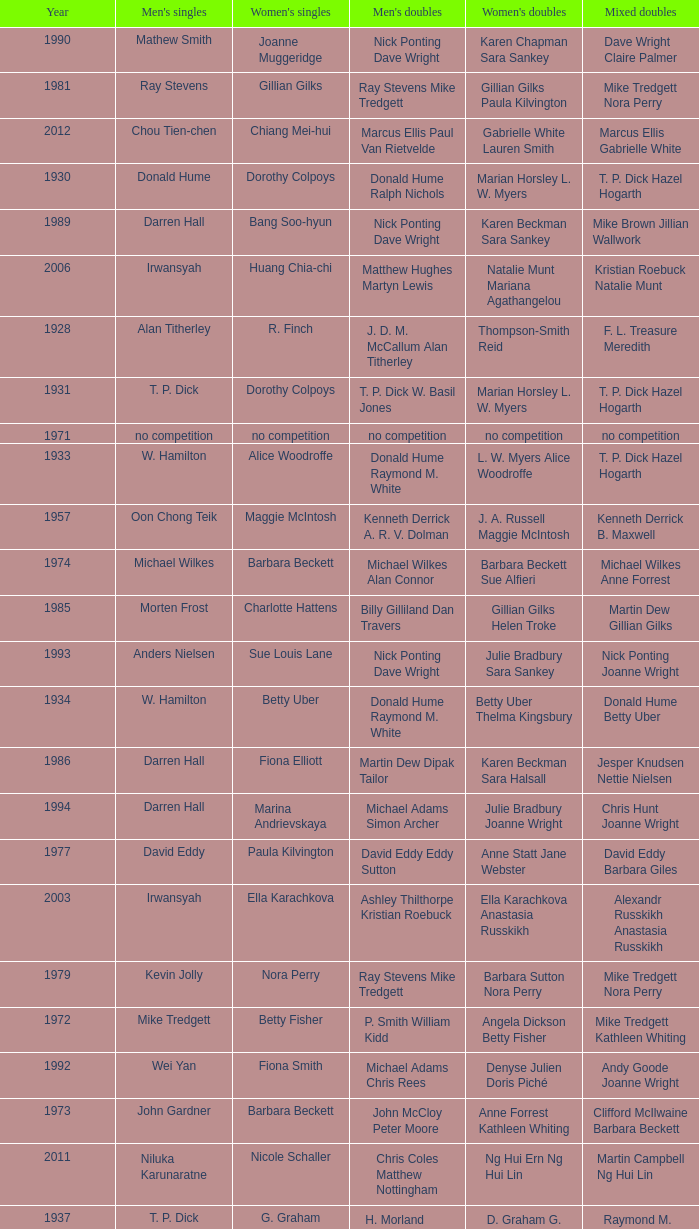Who won the Women's singles, in the year that Raymond M. White won the Men's singles and that W. Hamilton Ian Maconachie won the Men's doubles? Thelma Kingsbury. 